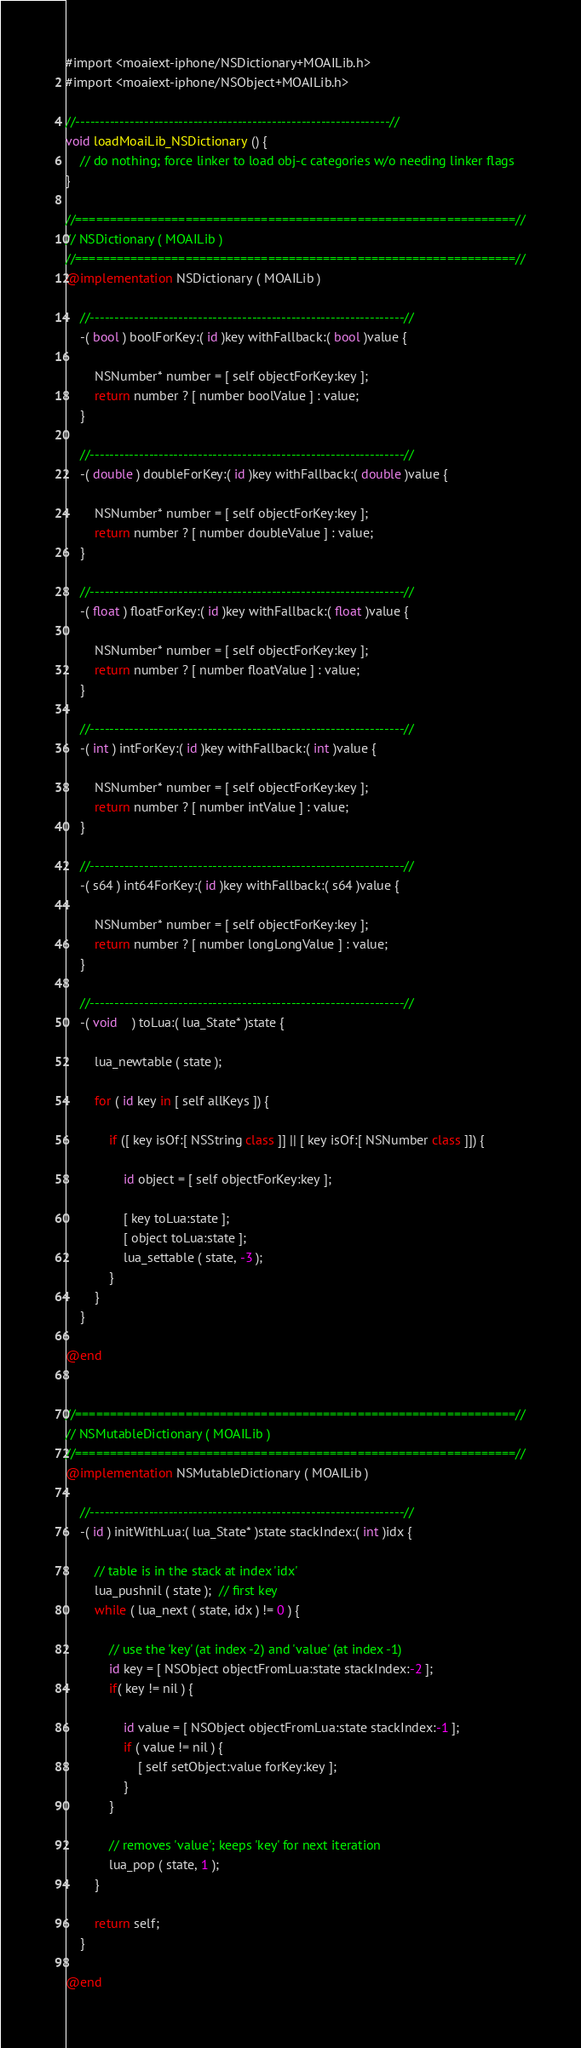<code> <loc_0><loc_0><loc_500><loc_500><_ObjectiveC_>#import <moaiext-iphone/NSDictionary+MOAILib.h>
#import <moaiext-iphone/NSObject+MOAILib.h>

//----------------------------------------------------------------//
void loadMoaiLib_NSDictionary () {
	// do nothing; force linker to load obj-c categories w/o needing linker flags
}

//================================================================//
// NSDictionary ( MOAILib )
//================================================================//
@implementation NSDictionary ( MOAILib )

	//----------------------------------------------------------------//
	-( bool ) boolForKey:( id )key withFallback:( bool )value {
	
		NSNumber* number = [ self objectForKey:key ];
		return number ? [ number boolValue ] : value;
	}
	
	//----------------------------------------------------------------//
	-( double ) doubleForKey:( id )key withFallback:( double )value {
	
		NSNumber* number = [ self objectForKey:key ];
		return number ? [ number doubleValue ] : value;
	}
	
	//----------------------------------------------------------------//
	-( float ) floatForKey:( id )key withFallback:( float )value {
	
		NSNumber* number = [ self objectForKey:key ];
		return number ? [ number floatValue ] : value;
	}
	
	//----------------------------------------------------------------//
	-( int ) intForKey:( id )key withFallback:( int )value {
	
		NSNumber* number = [ self objectForKey:key ];
		return number ? [ number intValue ] : value;
	}
	
	//----------------------------------------------------------------//
	-( s64 ) int64ForKey:( id )key withFallback:( s64 )value {
	
		NSNumber* number = [ self objectForKey:key ];
		return number ? [ number longLongValue ] : value;
	}
	
	//----------------------------------------------------------------//
	-( void	) toLua:( lua_State* )state {
		
		lua_newtable ( state );

		for ( id key in [ self allKeys ]) {
			
			if ([ key isOf:[ NSString class ]] || [ key isOf:[ NSNumber class ]]) {
				
				id object = [ self objectForKey:key ];
				
				[ key toLua:state ];
				[ object toLua:state ];
				lua_settable ( state, -3 );
			}
		}
	}

@end


//================================================================//
// NSMutableDictionary ( MOAILib )
//================================================================//
@implementation NSMutableDictionary ( MOAILib )

	//----------------------------------------------------------------//
	-( id ) initWithLua:( lua_State* )state stackIndex:( int )idx {

		// table is in the stack at index 'idx'
		lua_pushnil ( state );  // first key
		while ( lua_next ( state, idx ) != 0 ) {
			
			// use the 'key' (at index -2) and 'value' (at index -1)
			id key = [ NSObject objectFromLua:state stackIndex:-2 ];
			if( key != nil ) {
				
				id value = [ NSObject objectFromLua:state stackIndex:-1 ];
				if ( value != nil ) {
					[ self setObject:value forKey:key ];
				}
			}			
			
			// removes 'value'; keeps 'key' for next iteration
			lua_pop ( state, 1 );
		}
		
		return self;
	}

@end
</code> 